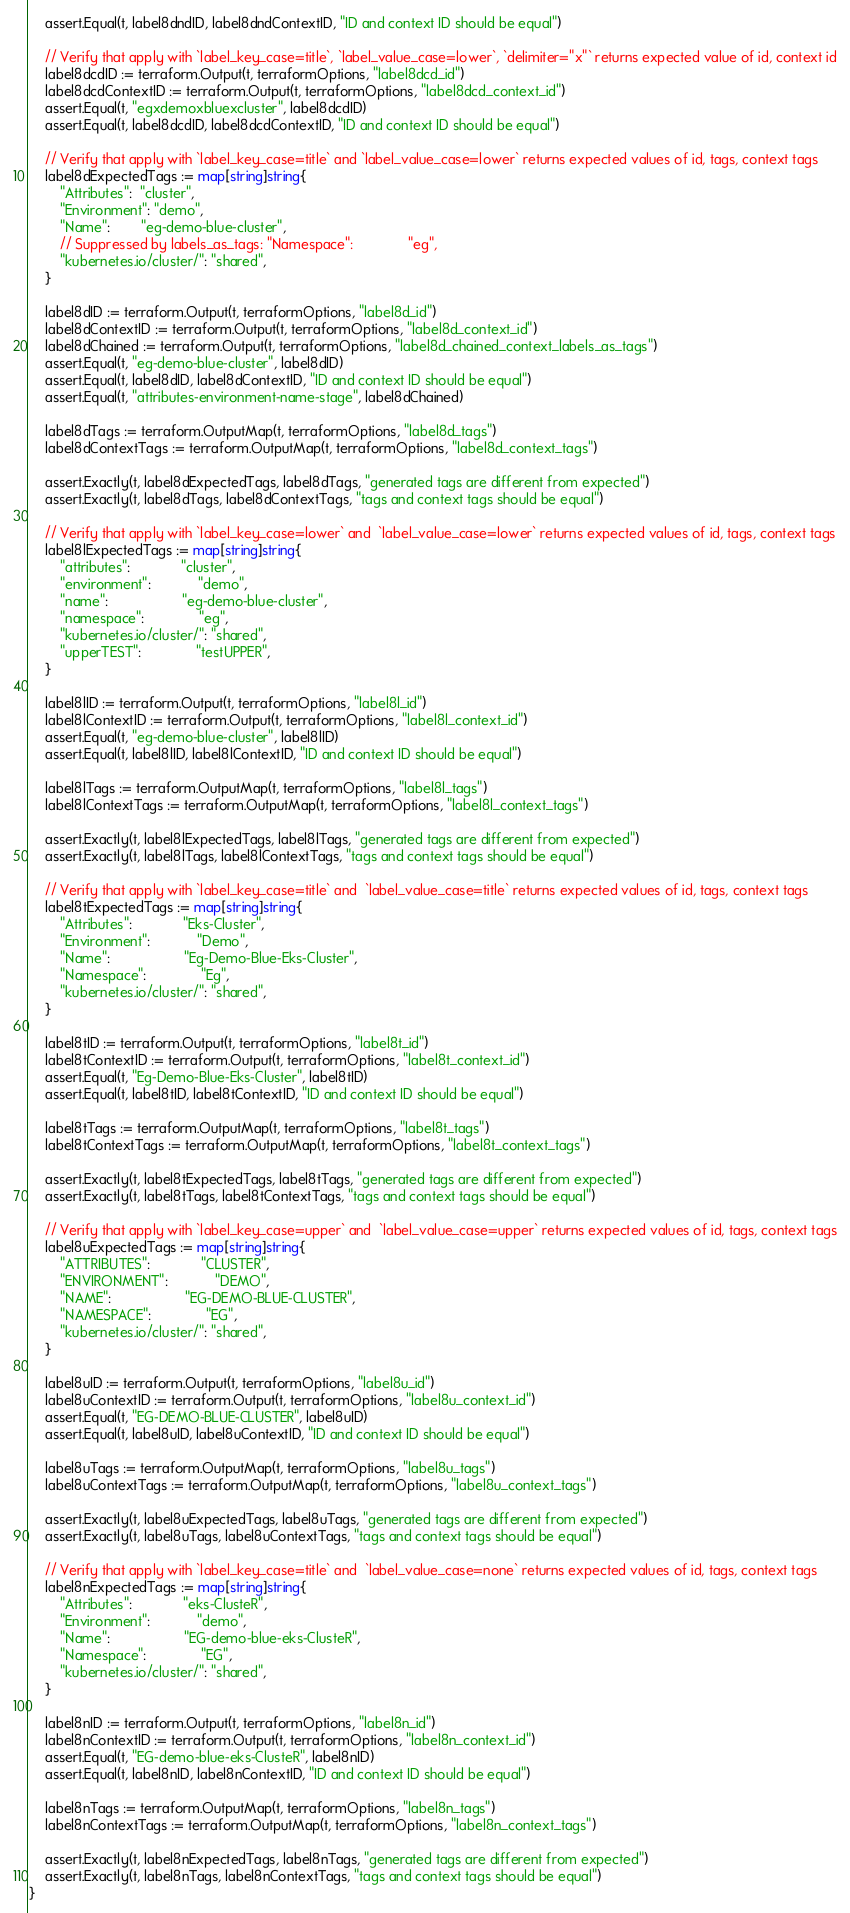Convert code to text. <code><loc_0><loc_0><loc_500><loc_500><_Go_>	assert.Equal(t, label8dndID, label8dndContextID, "ID and context ID should be equal")

	// Verify that apply with `label_key_case=title`, `label_value_case=lower`, `delimiter="x"` returns expected value of id, context id
	label8dcdID := terraform.Output(t, terraformOptions, "label8dcd_id")
	label8dcdContextID := terraform.Output(t, terraformOptions, "label8dcd_context_id")
	assert.Equal(t, "egxdemoxbluexcluster", label8dcdID)
	assert.Equal(t, label8dcdID, label8dcdContextID, "ID and context ID should be equal")

	// Verify that apply with `label_key_case=title` and `label_value_case=lower` returns expected values of id, tags, context tags
	label8dExpectedTags := map[string]string{
		"Attributes":  "cluster",
		"Environment": "demo",
		"Name":        "eg-demo-blue-cluster",
		// Suppressed by labels_as_tags: "Namespace":              "eg",
		"kubernetes.io/cluster/": "shared",
	}

	label8dID := terraform.Output(t, terraformOptions, "label8d_id")
	label8dContextID := terraform.Output(t, terraformOptions, "label8d_context_id")
	label8dChained := terraform.Output(t, terraformOptions, "label8d_chained_context_labels_as_tags")
	assert.Equal(t, "eg-demo-blue-cluster", label8dID)
	assert.Equal(t, label8dID, label8dContextID, "ID and context ID should be equal")
	assert.Equal(t, "attributes-environment-name-stage", label8dChained)

	label8dTags := terraform.OutputMap(t, terraformOptions, "label8d_tags")
	label8dContextTags := terraform.OutputMap(t, terraformOptions, "label8d_context_tags")

	assert.Exactly(t, label8dExpectedTags, label8dTags, "generated tags are different from expected")
	assert.Exactly(t, label8dTags, label8dContextTags, "tags and context tags should be equal")

	// Verify that apply with `label_key_case=lower` and  `label_value_case=lower` returns expected values of id, tags, context tags
	label8lExpectedTags := map[string]string{
		"attributes":             "cluster",
		"environment":            "demo",
		"name":                   "eg-demo-blue-cluster",
		"namespace":              "eg",
		"kubernetes.io/cluster/": "shared",
		"upperTEST":              "testUPPER",
	}

	label8lID := terraform.Output(t, terraformOptions, "label8l_id")
	label8lContextID := terraform.Output(t, terraformOptions, "label8l_context_id")
	assert.Equal(t, "eg-demo-blue-cluster", label8lID)
	assert.Equal(t, label8lID, label8lContextID, "ID and context ID should be equal")

	label8lTags := terraform.OutputMap(t, terraformOptions, "label8l_tags")
	label8lContextTags := terraform.OutputMap(t, terraformOptions, "label8l_context_tags")

	assert.Exactly(t, label8lExpectedTags, label8lTags, "generated tags are different from expected")
	assert.Exactly(t, label8lTags, label8lContextTags, "tags and context tags should be equal")

	// Verify that apply with `label_key_case=title` and  `label_value_case=title` returns expected values of id, tags, context tags
	label8tExpectedTags := map[string]string{
		"Attributes":             "Eks-Cluster",
		"Environment":            "Demo",
		"Name":                   "Eg-Demo-Blue-Eks-Cluster",
		"Namespace":              "Eg",
		"kubernetes.io/cluster/": "shared",
	}

	label8tID := terraform.Output(t, terraformOptions, "label8t_id")
	label8tContextID := terraform.Output(t, terraformOptions, "label8t_context_id")
	assert.Equal(t, "Eg-Demo-Blue-Eks-Cluster", label8tID)
	assert.Equal(t, label8tID, label8tContextID, "ID and context ID should be equal")

	label8tTags := terraform.OutputMap(t, terraformOptions, "label8t_tags")
	label8tContextTags := terraform.OutputMap(t, terraformOptions, "label8t_context_tags")

	assert.Exactly(t, label8tExpectedTags, label8tTags, "generated tags are different from expected")
	assert.Exactly(t, label8tTags, label8tContextTags, "tags and context tags should be equal")

	// Verify that apply with `label_key_case=upper` and  `label_value_case=upper` returns expected values of id, tags, context tags
	label8uExpectedTags := map[string]string{
		"ATTRIBUTES":             "CLUSTER",
		"ENVIRONMENT":            "DEMO",
		"NAME":                   "EG-DEMO-BLUE-CLUSTER",
		"NAMESPACE":              "EG",
		"kubernetes.io/cluster/": "shared",
	}

	label8uID := terraform.Output(t, terraformOptions, "label8u_id")
	label8uContextID := terraform.Output(t, terraformOptions, "label8u_context_id")
	assert.Equal(t, "EG-DEMO-BLUE-CLUSTER", label8uID)
	assert.Equal(t, label8uID, label8uContextID, "ID and context ID should be equal")

	label8uTags := terraform.OutputMap(t, terraformOptions, "label8u_tags")
	label8uContextTags := terraform.OutputMap(t, terraformOptions, "label8u_context_tags")

	assert.Exactly(t, label8uExpectedTags, label8uTags, "generated tags are different from expected")
	assert.Exactly(t, label8uTags, label8uContextTags, "tags and context tags should be equal")

	// Verify that apply with `label_key_case=title` and  `label_value_case=none` returns expected values of id, tags, context tags
	label8nExpectedTags := map[string]string{
		"Attributes":             "eks-ClusteR",
		"Environment":            "demo",
		"Name":                   "EG-demo-blue-eks-ClusteR",
		"Namespace":              "EG",
		"kubernetes.io/cluster/": "shared",
	}

	label8nID := terraform.Output(t, terraformOptions, "label8n_id")
	label8nContextID := terraform.Output(t, terraformOptions, "label8n_context_id")
	assert.Equal(t, "EG-demo-blue-eks-ClusteR", label8nID)
	assert.Equal(t, label8nID, label8nContextID, "ID and context ID should be equal")

	label8nTags := terraform.OutputMap(t, terraformOptions, "label8n_tags")
	label8nContextTags := terraform.OutputMap(t, terraformOptions, "label8n_context_tags")

	assert.Exactly(t, label8nExpectedTags, label8nTags, "generated tags are different from expected")
	assert.Exactly(t, label8nTags, label8nContextTags, "tags and context tags should be equal")
}
</code> 